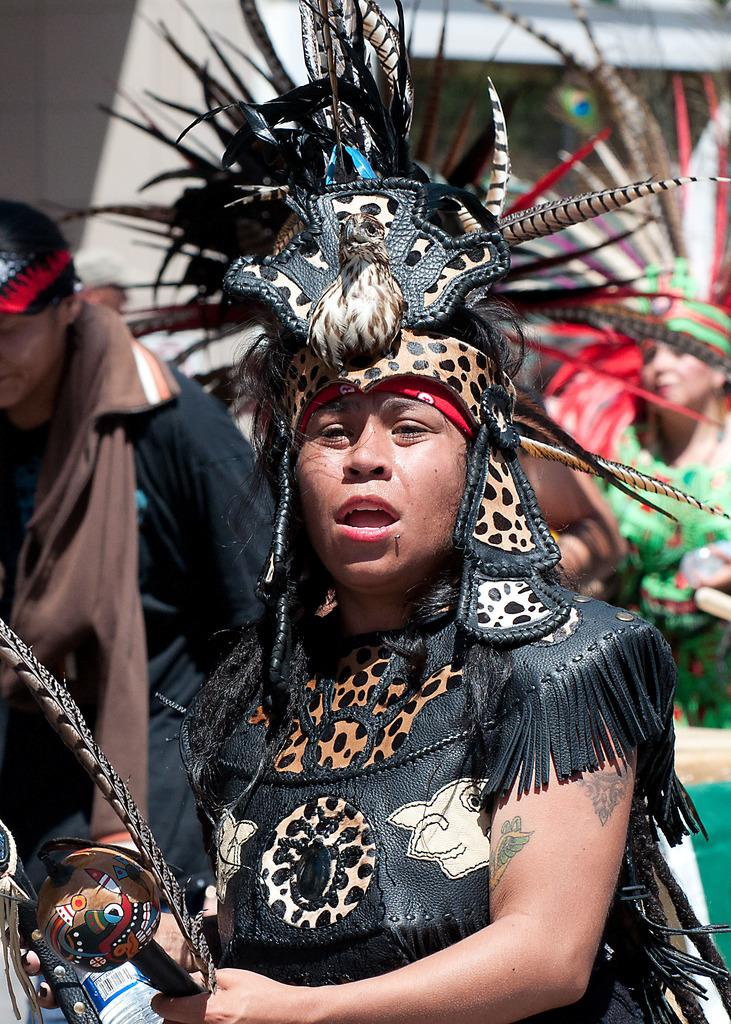How many people are in the image? There are three persons in the image. What are the costumes of the two persons? The two persons are in costume. What are the costumed persons holding? The two costumed persons are holding objects. What can be seen in the background of the image? There is a building visible in the background of the image. What type of soup is being served in the image? There is no soup present in the image. How many crates are visible in the image? There are no crates visible in the image. 